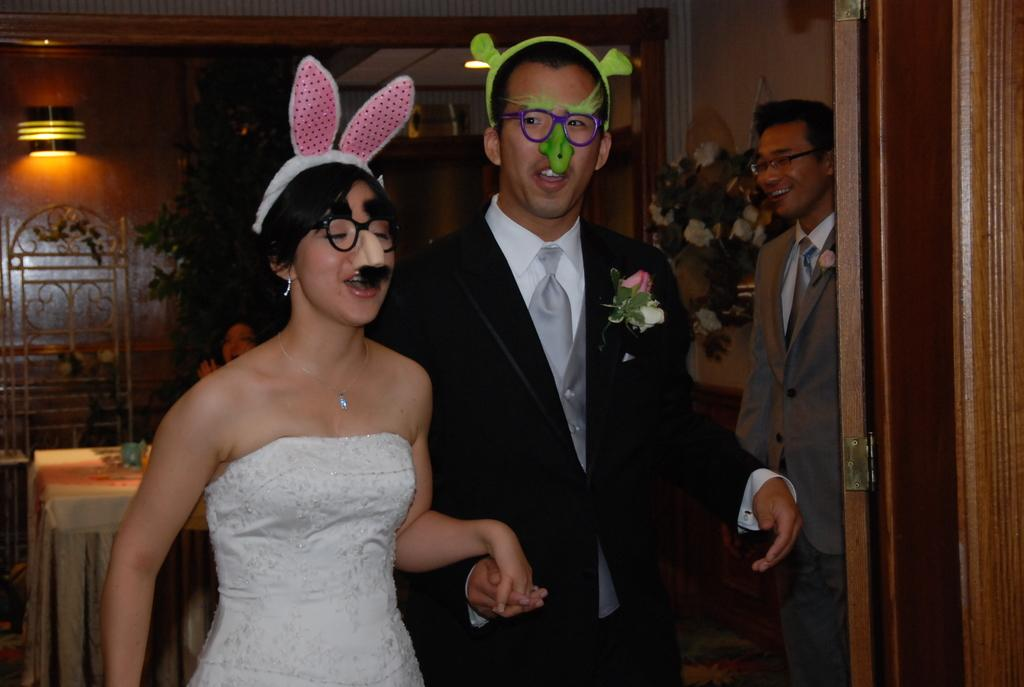How many people are in the image? There are three people in the image. Can you describe the gender of the people in the image? Two of them are men, and one of them is a woman. What can be seen in the background of the image? There is a plant and a wall in the background of the image. What type of toothpaste is the woman using in the image? There is no toothpaste present in the image; it features three people and a background with a plant and a wall. 